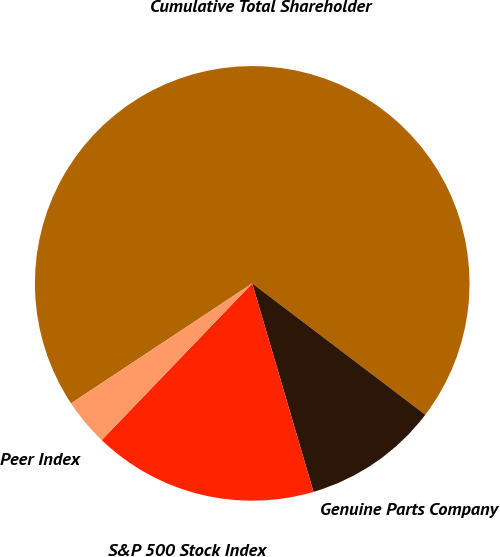<chart> <loc_0><loc_0><loc_500><loc_500><pie_chart><fcel>Cumulative Total Shareholder<fcel>Genuine Parts Company<fcel>S&P 500 Stock Index<fcel>Peer Index<nl><fcel>69.64%<fcel>10.12%<fcel>16.73%<fcel>3.51%<nl></chart> 